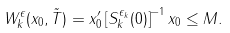<formula> <loc_0><loc_0><loc_500><loc_500>W ^ { \epsilon } _ { k } ( x _ { 0 } , \tilde { T } ) = x _ { 0 } ^ { \prime } \left [ S ^ { \epsilon _ { k } } _ { k } ( 0 ) \right ] ^ { - 1 } x _ { 0 } \leq M .</formula> 